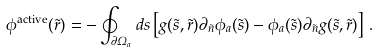<formula> <loc_0><loc_0><loc_500><loc_500>\phi ^ { \text {active} } ( \vec { r } ) = - \oint _ { \partial \Omega _ { a } } d s \left [ g ( { \vec { s } } , { \vec { r } } ) \partial _ { \vec { n } } \phi _ { a } ( { \vec { s } } ) - \phi _ { a } ( { \vec { s } } ) \partial _ { \vec { n } } g ( { \vec { s } } , { \vec { r } } ) \right ] \, .</formula> 